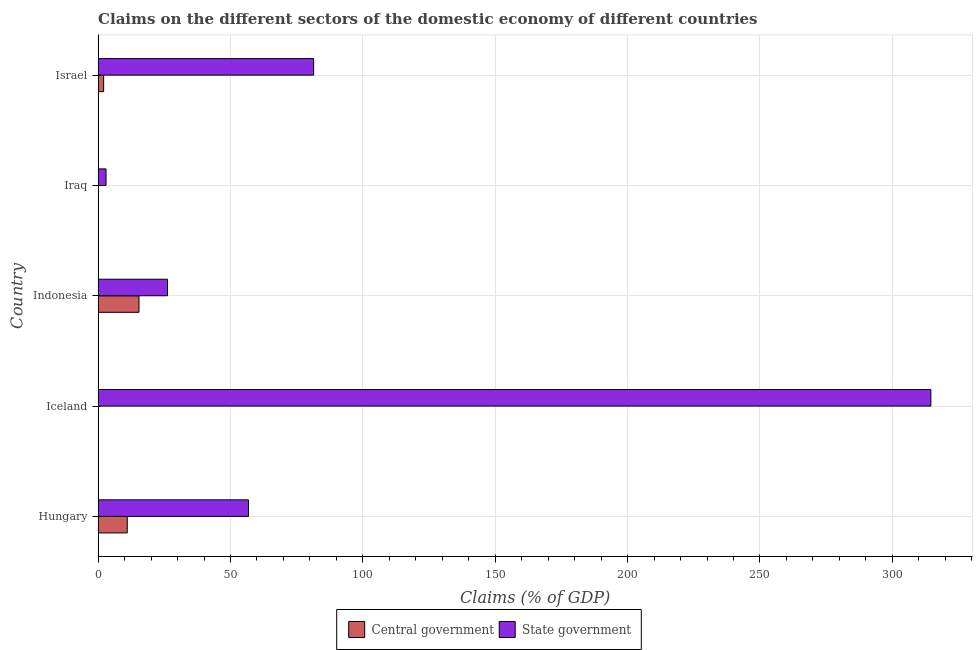How many different coloured bars are there?
Keep it short and to the point. 2. Are the number of bars on each tick of the Y-axis equal?
Your answer should be very brief. No. How many bars are there on the 1st tick from the top?
Offer a terse response. 2. How many bars are there on the 1st tick from the bottom?
Offer a terse response. 2. In how many cases, is the number of bars for a given country not equal to the number of legend labels?
Give a very brief answer. 2. What is the claims on state government in Hungary?
Your answer should be compact. 56.81. Across all countries, what is the maximum claims on central government?
Ensure brevity in your answer.  15.44. What is the total claims on state government in the graph?
Your answer should be compact. 481.98. What is the difference between the claims on central government in Indonesia and that in Israel?
Your answer should be compact. 13.35. What is the difference between the claims on central government in Indonesia and the claims on state government in Iceland?
Your answer should be compact. -299.11. What is the average claims on state government per country?
Keep it short and to the point. 96.39. What is the difference between the claims on state government and claims on central government in Israel?
Offer a terse response. 79.33. What is the ratio of the claims on state government in Iceland to that in Indonesia?
Offer a terse response. 12. What is the difference between the highest and the second highest claims on state government?
Offer a terse response. 233.13. What is the difference between the highest and the lowest claims on central government?
Offer a terse response. 15.44. Is the sum of the claims on state government in Indonesia and Israel greater than the maximum claims on central government across all countries?
Your response must be concise. Yes. Are the values on the major ticks of X-axis written in scientific E-notation?
Offer a very short reply. No. Where does the legend appear in the graph?
Make the answer very short. Bottom center. How are the legend labels stacked?
Keep it short and to the point. Horizontal. What is the title of the graph?
Ensure brevity in your answer.  Claims on the different sectors of the domestic economy of different countries. Does "Quasi money growth" appear as one of the legend labels in the graph?
Make the answer very short. No. What is the label or title of the X-axis?
Provide a succinct answer. Claims (% of GDP). What is the label or title of the Y-axis?
Offer a terse response. Country. What is the Claims (% of GDP) of Central government in Hungary?
Make the answer very short. 11. What is the Claims (% of GDP) in State government in Hungary?
Your response must be concise. 56.81. What is the Claims (% of GDP) of Central government in Iceland?
Your answer should be very brief. 0. What is the Claims (% of GDP) in State government in Iceland?
Make the answer very short. 314.55. What is the Claims (% of GDP) in Central government in Indonesia?
Your answer should be compact. 15.44. What is the Claims (% of GDP) in State government in Indonesia?
Offer a very short reply. 26.22. What is the Claims (% of GDP) of State government in Iraq?
Your answer should be very brief. 2.99. What is the Claims (% of GDP) in Central government in Israel?
Ensure brevity in your answer.  2.09. What is the Claims (% of GDP) in State government in Israel?
Keep it short and to the point. 81.42. Across all countries, what is the maximum Claims (% of GDP) in Central government?
Your answer should be very brief. 15.44. Across all countries, what is the maximum Claims (% of GDP) in State government?
Your answer should be very brief. 314.55. Across all countries, what is the minimum Claims (% of GDP) in Central government?
Offer a very short reply. 0. Across all countries, what is the minimum Claims (% of GDP) of State government?
Offer a terse response. 2.99. What is the total Claims (% of GDP) in Central government in the graph?
Make the answer very short. 28.53. What is the total Claims (% of GDP) of State government in the graph?
Offer a terse response. 481.98. What is the difference between the Claims (% of GDP) in State government in Hungary and that in Iceland?
Offer a very short reply. -257.74. What is the difference between the Claims (% of GDP) of Central government in Hungary and that in Indonesia?
Give a very brief answer. -4.44. What is the difference between the Claims (% of GDP) of State government in Hungary and that in Indonesia?
Offer a very short reply. 30.59. What is the difference between the Claims (% of GDP) of State government in Hungary and that in Iraq?
Your response must be concise. 53.82. What is the difference between the Claims (% of GDP) in Central government in Hungary and that in Israel?
Ensure brevity in your answer.  8.91. What is the difference between the Claims (% of GDP) of State government in Hungary and that in Israel?
Provide a short and direct response. -24.61. What is the difference between the Claims (% of GDP) of State government in Iceland and that in Indonesia?
Provide a short and direct response. 288.33. What is the difference between the Claims (% of GDP) of State government in Iceland and that in Iraq?
Your response must be concise. 311.56. What is the difference between the Claims (% of GDP) in State government in Iceland and that in Israel?
Your response must be concise. 233.13. What is the difference between the Claims (% of GDP) in State government in Indonesia and that in Iraq?
Your response must be concise. 23.23. What is the difference between the Claims (% of GDP) of Central government in Indonesia and that in Israel?
Your answer should be compact. 13.35. What is the difference between the Claims (% of GDP) in State government in Indonesia and that in Israel?
Offer a very short reply. -55.2. What is the difference between the Claims (% of GDP) of State government in Iraq and that in Israel?
Offer a very short reply. -78.43. What is the difference between the Claims (% of GDP) in Central government in Hungary and the Claims (% of GDP) in State government in Iceland?
Offer a terse response. -303.55. What is the difference between the Claims (% of GDP) in Central government in Hungary and the Claims (% of GDP) in State government in Indonesia?
Offer a terse response. -15.22. What is the difference between the Claims (% of GDP) of Central government in Hungary and the Claims (% of GDP) of State government in Iraq?
Keep it short and to the point. 8.01. What is the difference between the Claims (% of GDP) of Central government in Hungary and the Claims (% of GDP) of State government in Israel?
Offer a terse response. -70.42. What is the difference between the Claims (% of GDP) in Central government in Indonesia and the Claims (% of GDP) in State government in Iraq?
Keep it short and to the point. 12.45. What is the difference between the Claims (% of GDP) of Central government in Indonesia and the Claims (% of GDP) of State government in Israel?
Ensure brevity in your answer.  -65.97. What is the average Claims (% of GDP) of Central government per country?
Give a very brief answer. 5.71. What is the average Claims (% of GDP) in State government per country?
Make the answer very short. 96.4. What is the difference between the Claims (% of GDP) in Central government and Claims (% of GDP) in State government in Hungary?
Provide a succinct answer. -45.8. What is the difference between the Claims (% of GDP) of Central government and Claims (% of GDP) of State government in Indonesia?
Offer a terse response. -10.77. What is the difference between the Claims (% of GDP) in Central government and Claims (% of GDP) in State government in Israel?
Offer a very short reply. -79.33. What is the ratio of the Claims (% of GDP) in State government in Hungary to that in Iceland?
Your response must be concise. 0.18. What is the ratio of the Claims (% of GDP) of Central government in Hungary to that in Indonesia?
Provide a short and direct response. 0.71. What is the ratio of the Claims (% of GDP) in State government in Hungary to that in Indonesia?
Your response must be concise. 2.17. What is the ratio of the Claims (% of GDP) in State government in Hungary to that in Iraq?
Offer a terse response. 19.01. What is the ratio of the Claims (% of GDP) in Central government in Hungary to that in Israel?
Make the answer very short. 5.27. What is the ratio of the Claims (% of GDP) in State government in Hungary to that in Israel?
Your answer should be compact. 0.7. What is the ratio of the Claims (% of GDP) in State government in Iceland to that in Indonesia?
Ensure brevity in your answer.  12. What is the ratio of the Claims (% of GDP) of State government in Iceland to that in Iraq?
Your answer should be very brief. 105.27. What is the ratio of the Claims (% of GDP) in State government in Iceland to that in Israel?
Your answer should be very brief. 3.86. What is the ratio of the Claims (% of GDP) of State government in Indonesia to that in Iraq?
Your response must be concise. 8.77. What is the ratio of the Claims (% of GDP) in Central government in Indonesia to that in Israel?
Your response must be concise. 7.39. What is the ratio of the Claims (% of GDP) of State government in Indonesia to that in Israel?
Your answer should be compact. 0.32. What is the ratio of the Claims (% of GDP) in State government in Iraq to that in Israel?
Ensure brevity in your answer.  0.04. What is the difference between the highest and the second highest Claims (% of GDP) in Central government?
Offer a terse response. 4.44. What is the difference between the highest and the second highest Claims (% of GDP) in State government?
Provide a short and direct response. 233.13. What is the difference between the highest and the lowest Claims (% of GDP) in Central government?
Keep it short and to the point. 15.44. What is the difference between the highest and the lowest Claims (% of GDP) in State government?
Make the answer very short. 311.56. 